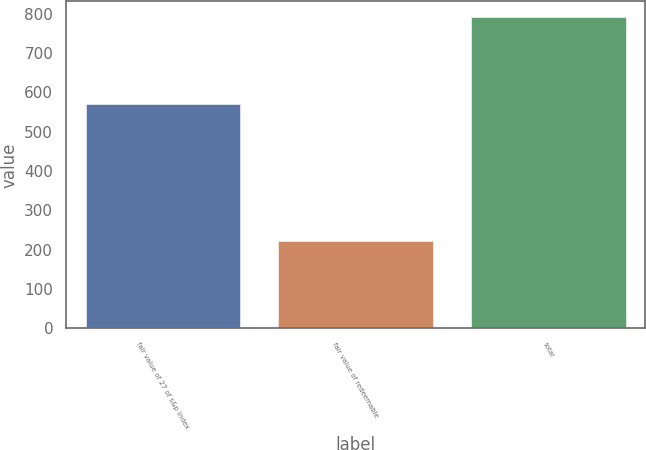Convert chart. <chart><loc_0><loc_0><loc_500><loc_500><bar_chart><fcel>fair value of 27 of s&p index<fcel>fair value of redeemable<fcel>total<nl><fcel>571<fcel>221<fcel>792<nl></chart> 